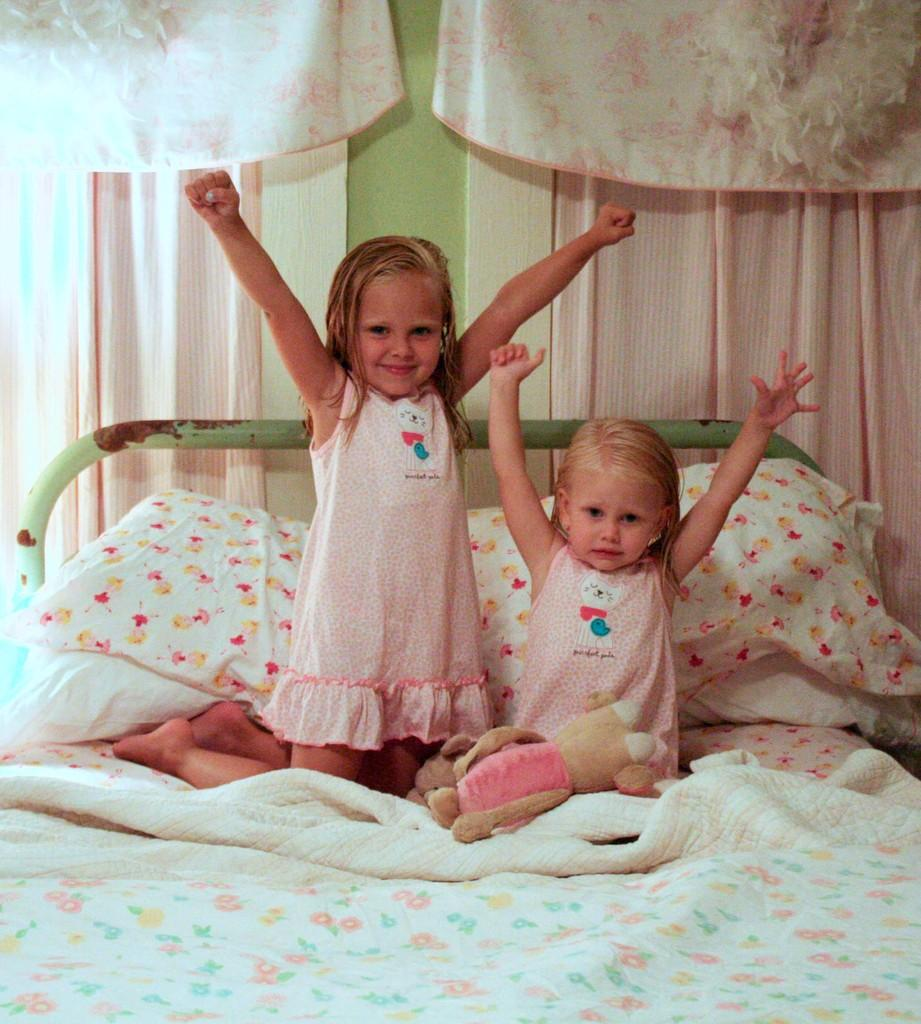What is located at the bottom of the image? There is a bed at the bottom of the image. What are the girls doing on the bed? The girls are sitting on the bed. What is the facial expression of the girls? The girls are smiling. What is on the wall at the top of the image? There is a curtain on the wall. How many planes can be seen flying in the image? There are no planes visible in the image. Is there a person taking a bath in the image? There is no person taking a bath in the image. 